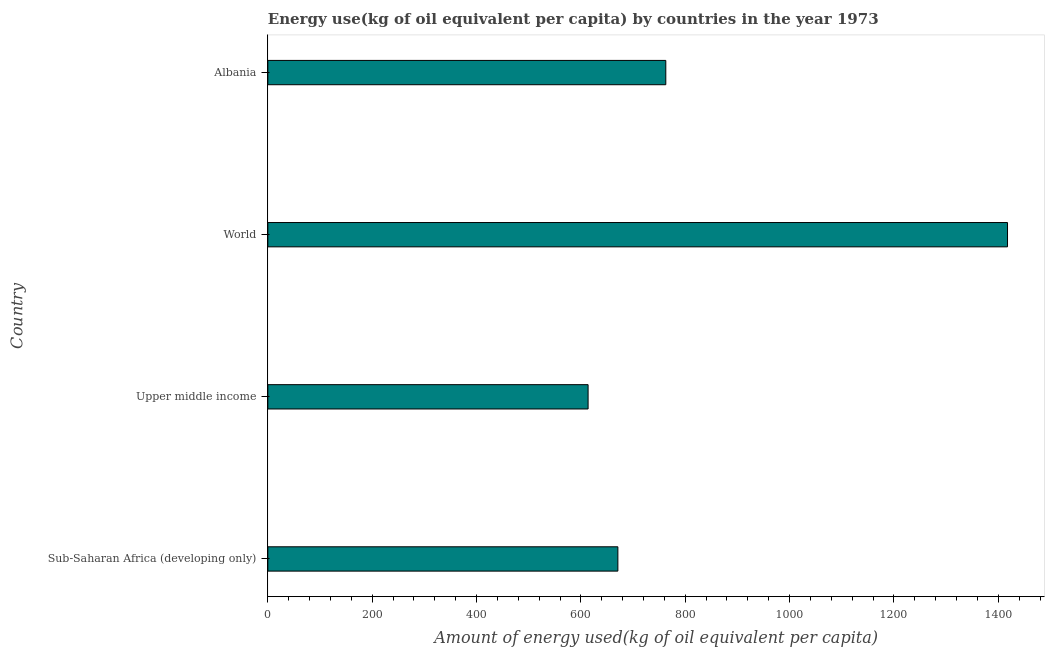Does the graph contain any zero values?
Ensure brevity in your answer.  No. Does the graph contain grids?
Offer a very short reply. No. What is the title of the graph?
Give a very brief answer. Energy use(kg of oil equivalent per capita) by countries in the year 1973. What is the label or title of the X-axis?
Offer a very short reply. Amount of energy used(kg of oil equivalent per capita). What is the label or title of the Y-axis?
Provide a short and direct response. Country. What is the amount of energy used in Albania?
Make the answer very short. 762.73. Across all countries, what is the maximum amount of energy used?
Provide a succinct answer. 1417.68. Across all countries, what is the minimum amount of energy used?
Give a very brief answer. 613.81. In which country was the amount of energy used minimum?
Give a very brief answer. Upper middle income. What is the sum of the amount of energy used?
Your answer should be very brief. 3465.11. What is the difference between the amount of energy used in Sub-Saharan Africa (developing only) and World?
Your answer should be very brief. -746.79. What is the average amount of energy used per country?
Your answer should be very brief. 866.28. What is the median amount of energy used?
Provide a short and direct response. 716.81. In how many countries, is the amount of energy used greater than 920 kg?
Your response must be concise. 1. What is the ratio of the amount of energy used in Albania to that in Upper middle income?
Offer a very short reply. 1.24. What is the difference between the highest and the second highest amount of energy used?
Offer a terse response. 654.96. Is the sum of the amount of energy used in Sub-Saharan Africa (developing only) and World greater than the maximum amount of energy used across all countries?
Give a very brief answer. Yes. What is the difference between the highest and the lowest amount of energy used?
Give a very brief answer. 803.87. In how many countries, is the amount of energy used greater than the average amount of energy used taken over all countries?
Keep it short and to the point. 1. How many bars are there?
Offer a terse response. 4. Are all the bars in the graph horizontal?
Keep it short and to the point. Yes. What is the difference between two consecutive major ticks on the X-axis?
Offer a terse response. 200. What is the Amount of energy used(kg of oil equivalent per capita) in Sub-Saharan Africa (developing only)?
Offer a terse response. 670.89. What is the Amount of energy used(kg of oil equivalent per capita) in Upper middle income?
Provide a short and direct response. 613.81. What is the Amount of energy used(kg of oil equivalent per capita) of World?
Your answer should be compact. 1417.68. What is the Amount of energy used(kg of oil equivalent per capita) of Albania?
Provide a short and direct response. 762.73. What is the difference between the Amount of energy used(kg of oil equivalent per capita) in Sub-Saharan Africa (developing only) and Upper middle income?
Your answer should be very brief. 57.08. What is the difference between the Amount of energy used(kg of oil equivalent per capita) in Sub-Saharan Africa (developing only) and World?
Give a very brief answer. -746.79. What is the difference between the Amount of energy used(kg of oil equivalent per capita) in Sub-Saharan Africa (developing only) and Albania?
Offer a terse response. -91.83. What is the difference between the Amount of energy used(kg of oil equivalent per capita) in Upper middle income and World?
Your answer should be compact. -803.87. What is the difference between the Amount of energy used(kg of oil equivalent per capita) in Upper middle income and Albania?
Provide a short and direct response. -148.91. What is the difference between the Amount of energy used(kg of oil equivalent per capita) in World and Albania?
Your answer should be compact. 654.96. What is the ratio of the Amount of energy used(kg of oil equivalent per capita) in Sub-Saharan Africa (developing only) to that in Upper middle income?
Provide a short and direct response. 1.09. What is the ratio of the Amount of energy used(kg of oil equivalent per capita) in Sub-Saharan Africa (developing only) to that in World?
Your answer should be compact. 0.47. What is the ratio of the Amount of energy used(kg of oil equivalent per capita) in Upper middle income to that in World?
Offer a very short reply. 0.43. What is the ratio of the Amount of energy used(kg of oil equivalent per capita) in Upper middle income to that in Albania?
Give a very brief answer. 0.81. What is the ratio of the Amount of energy used(kg of oil equivalent per capita) in World to that in Albania?
Your answer should be compact. 1.86. 